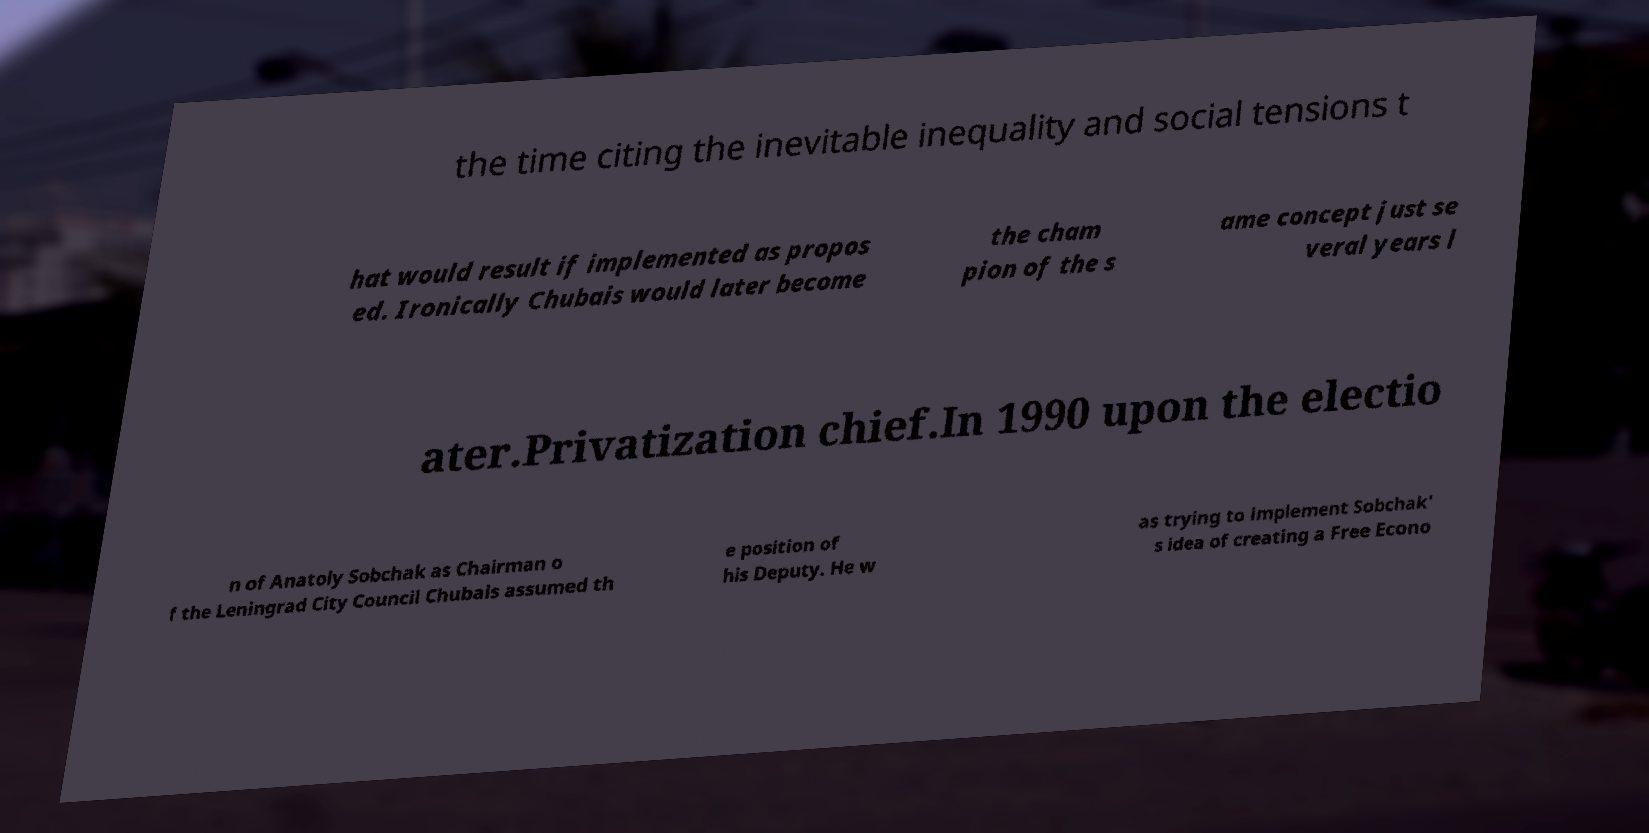Can you accurately transcribe the text from the provided image for me? the time citing the inevitable inequality and social tensions t hat would result if implemented as propos ed. Ironically Chubais would later become the cham pion of the s ame concept just se veral years l ater.Privatization chief.In 1990 upon the electio n of Anatoly Sobchak as Chairman o f the Leningrad City Council Chubais assumed th e position of his Deputy. He w as trying to implement Sobchak' s idea of creating a Free Econo 